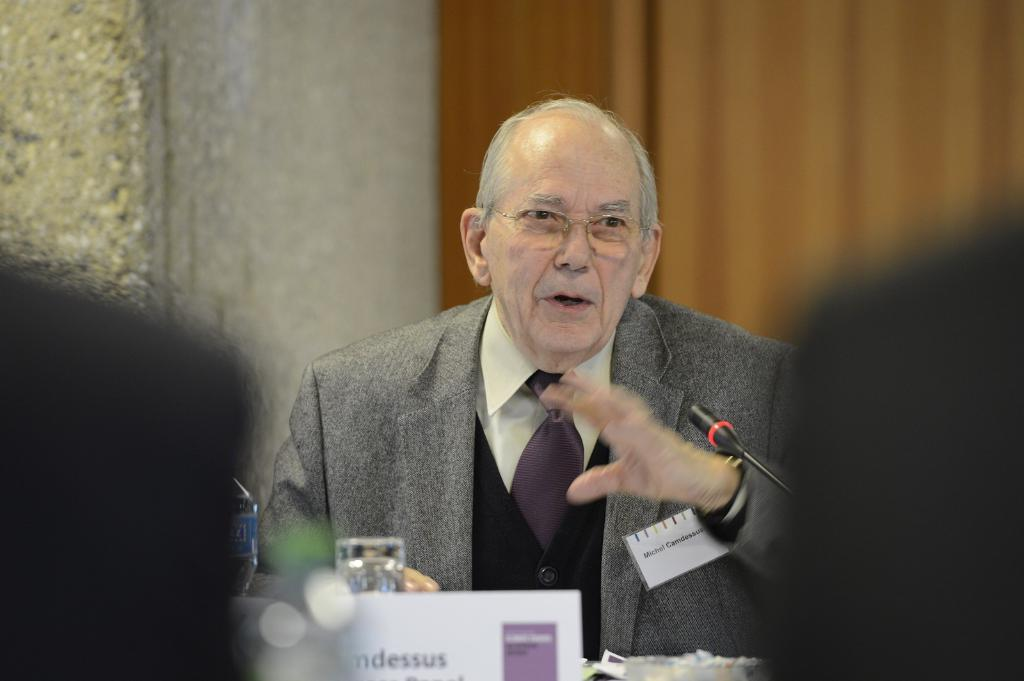Provide a one-sentence caption for the provided image. An older man with the name tag Michael Gamdessus is speaking. 